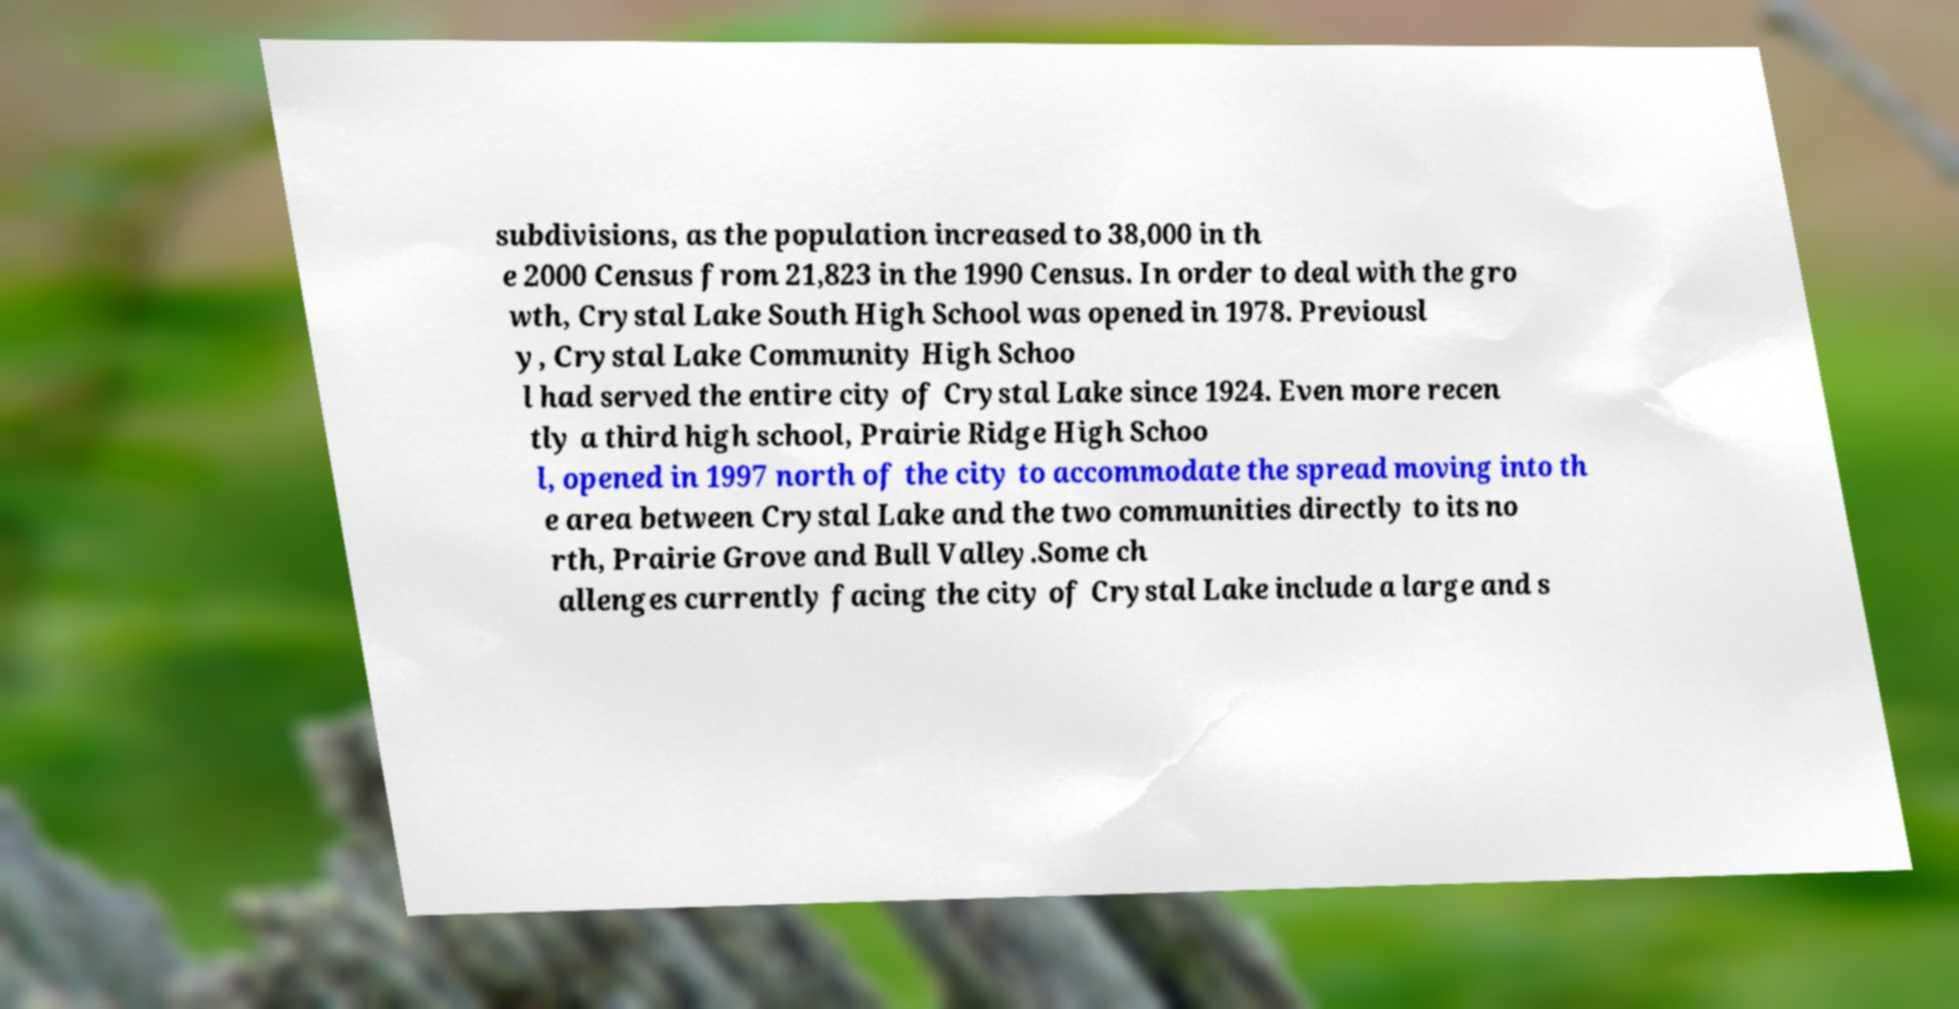Could you assist in decoding the text presented in this image and type it out clearly? subdivisions, as the population increased to 38,000 in th e 2000 Census from 21,823 in the 1990 Census. In order to deal with the gro wth, Crystal Lake South High School was opened in 1978. Previousl y, Crystal Lake Community High Schoo l had served the entire city of Crystal Lake since 1924. Even more recen tly a third high school, Prairie Ridge High Schoo l, opened in 1997 north of the city to accommodate the spread moving into th e area between Crystal Lake and the two communities directly to its no rth, Prairie Grove and Bull Valley.Some ch allenges currently facing the city of Crystal Lake include a large and s 